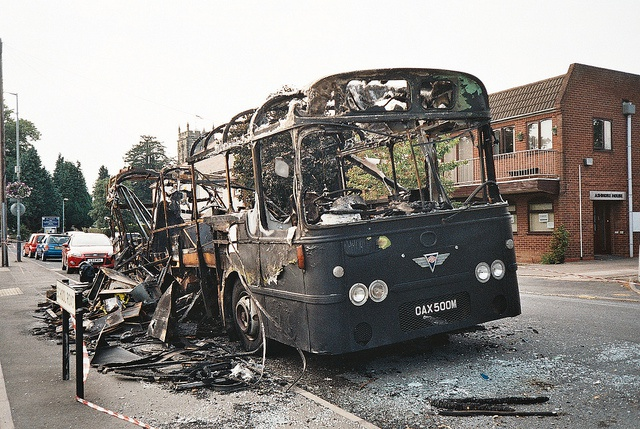Describe the objects in this image and their specific colors. I can see bus in white, black, gray, darkgray, and lightgray tones, car in white, black, maroon, and gray tones, car in white, black, gray, lightgray, and darkgray tones, and car in white, brown, darkgray, and lightpink tones in this image. 